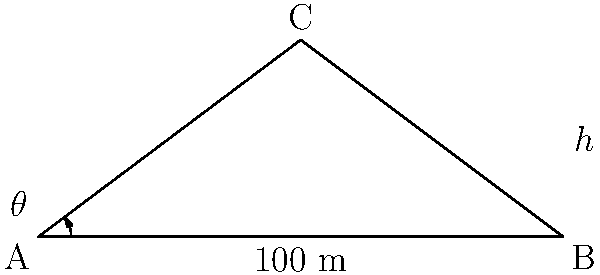A high-speed rail project requires constructing a bridge across a valley. The valley is 100 meters wide at the base, and the bridge needs to reach a height of 30 meters at its center. To minimize construction costs, engineers need to determine the optimal angle $\theta$ for the bridge's slope. What is the value of $\theta$ in degrees, rounded to two decimal places? Let's approach this step-by-step:

1) First, we need to recognize that the bridge forms two right-angled triangles. We'll focus on one of these triangles.

2) In this right-angled triangle:
   - The base (half of the valley width) is 50 meters (100/2)
   - The height is 30 meters

3) We can use the tangent function to find the angle $\theta$:

   $\tan(\theta) = \frac{\text{opposite}}{\text{adjacent}} = \frac{\text{height}}{\text{half width}} = \frac{30}{50}$

4) To find $\theta$, we need to use the inverse tangent (arctan or $\tan^{-1}$):

   $\theta = \tan^{-1}(\frac{30}{50})$

5) Using a calculator or computer:

   $\theta = \tan^{-1}(0.6) \approx 30.9638$ degrees

6) Rounding to two decimal places:

   $\theta \approx 30.96$ degrees

This angle will provide the optimal slope for the bridge, minimizing the construction costs by balancing the length of the bridge against its height.
Answer: $30.96^\circ$ 